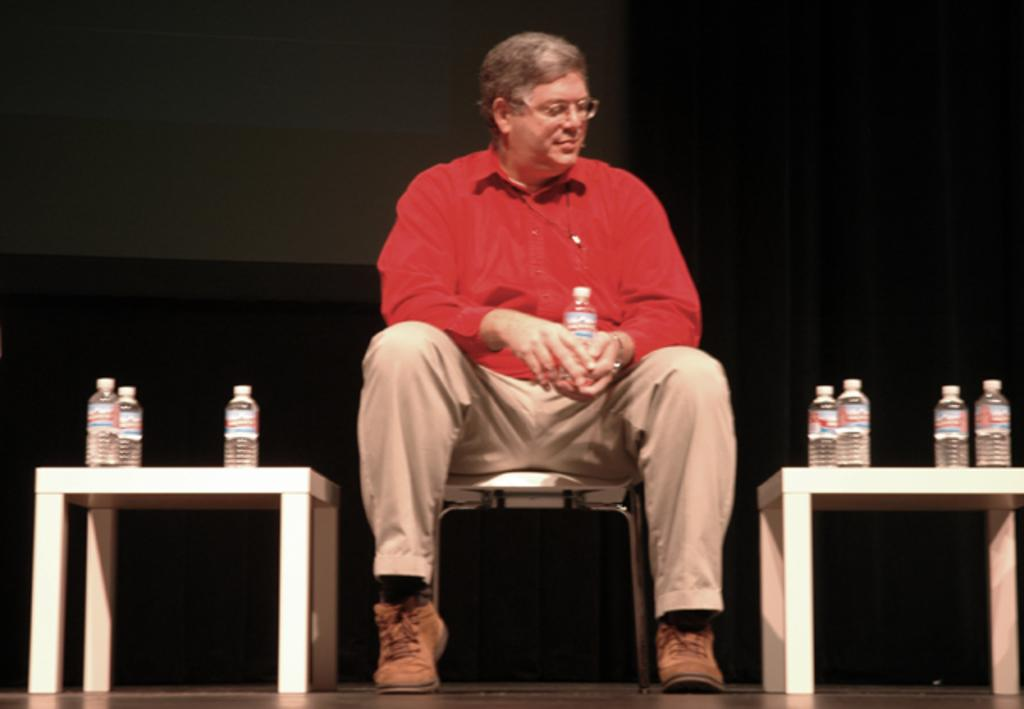What type of furniture is present in the image? There are tables in the image. What is the man in the image doing? A man is sitting on a chair in the image. What objects can be seen on the tables? There are bottles on the tables. What type of butter is being spread on the chin of the man in the image? There is no butter or chin-related activity present in the image. How many bears are visible in the image? There are no bears present in the image. 